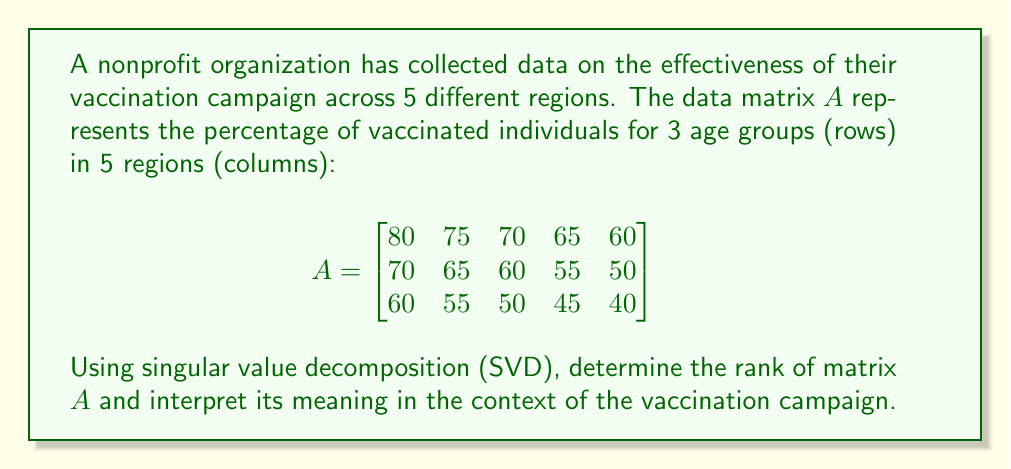Solve this math problem. To solve this problem, we'll follow these steps:

1) Perform Singular Value Decomposition (SVD) on matrix $A$.
2) Analyze the singular values to determine the rank.
3) Interpret the result in the context of the vaccination campaign.

Step 1: Perform SVD

The SVD of matrix $A$ is given by $A = U\Sigma V^T$, where $U$ and $V$ are orthogonal matrices and $\Sigma$ is a diagonal matrix containing the singular values.

Using a computational tool, we find the singular values:

$$\sigma_1 \approx 250.87$$
$$\sigma_2 \approx 13.37$$
$$\sigma_3 \approx 0.76$$

Step 2: Determine the rank

The rank of a matrix is equal to the number of non-zero singular values. In practice, we consider singular values very close to zero (relative to the largest singular value) as effectively zero due to numerical precision.

In this case, all three singular values are significantly different from zero, so:

Rank$(A) = 3$

Step 3: Interpretation

The rank of the matrix represents the number of linearly independent patterns or factors in the data. In this context:

- A rank of 3 indicates that there are three independent factors influencing vaccination rates across regions and age groups.
- These factors could represent:
  1. Overall vaccination willingness in each region
  2. Age-related differences in vaccination rates
  3. Interaction between region-specific and age-specific factors

This suggests that the vaccination campaign's effectiveness varies both by region and age group in a non-trivial way, and that all three age groups contribute unique information to the overall vaccination pattern.
Answer: Rank$(A) = 3$, indicating three independent factors influencing vaccination rates. 